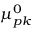Convert formula to latex. <formula><loc_0><loc_0><loc_500><loc_500>{ \, \mu ^ { 0 } } _ { p k }</formula> 